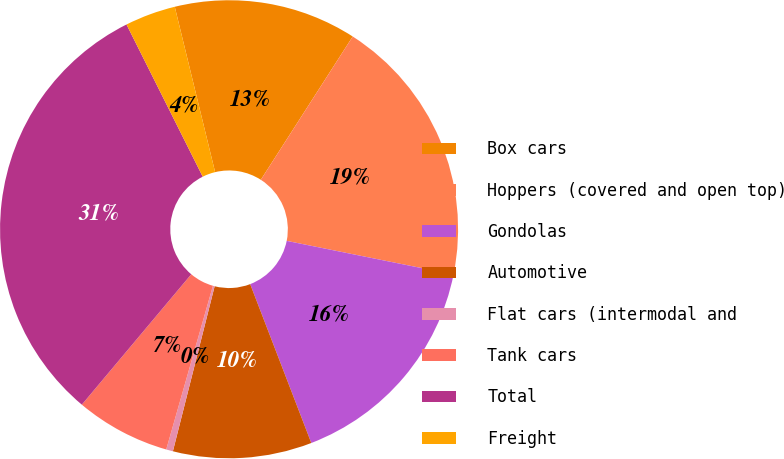<chart> <loc_0><loc_0><loc_500><loc_500><pie_chart><fcel>Box cars<fcel>Hoppers (covered and open top)<fcel>Gondolas<fcel>Automotive<fcel>Flat cars (intermodal and<fcel>Tank cars<fcel>Total<fcel>Freight<nl><fcel>12.89%<fcel>19.09%<fcel>15.99%<fcel>9.79%<fcel>0.48%<fcel>6.69%<fcel>31.5%<fcel>3.58%<nl></chart> 